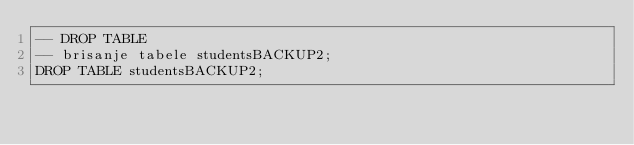Convert code to text. <code><loc_0><loc_0><loc_500><loc_500><_SQL_>-- DROP TABLE
-- brisanje tabele studentsBACKUP2;
DROP TABLE studentsBACKUP2;
</code> 